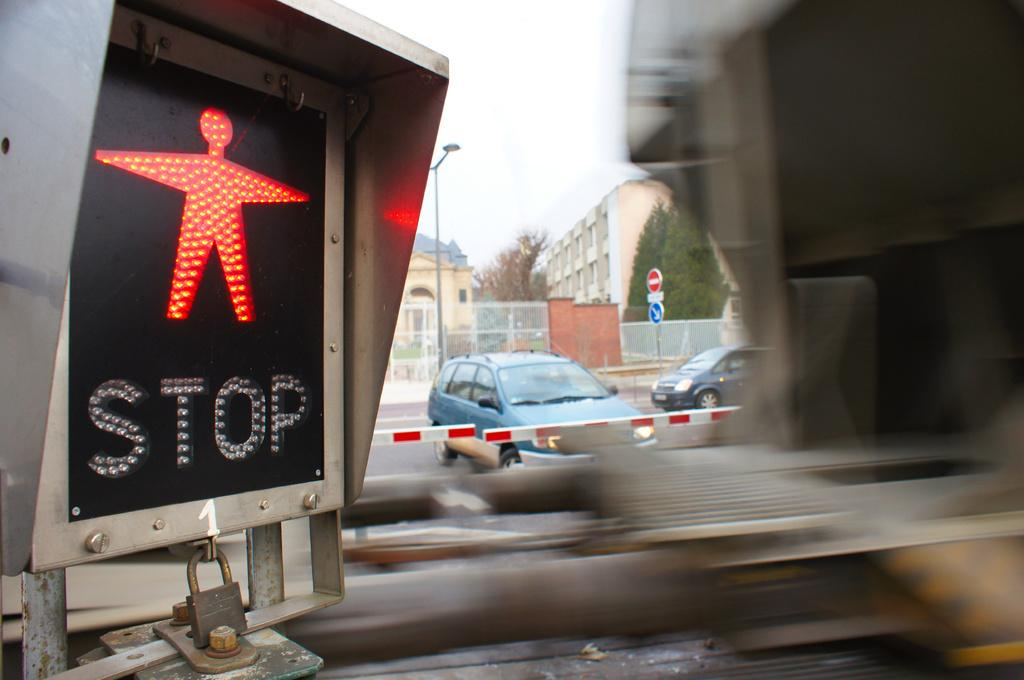<image>
Share a concise interpretation of the image provided. a stop sign that is for people walking 